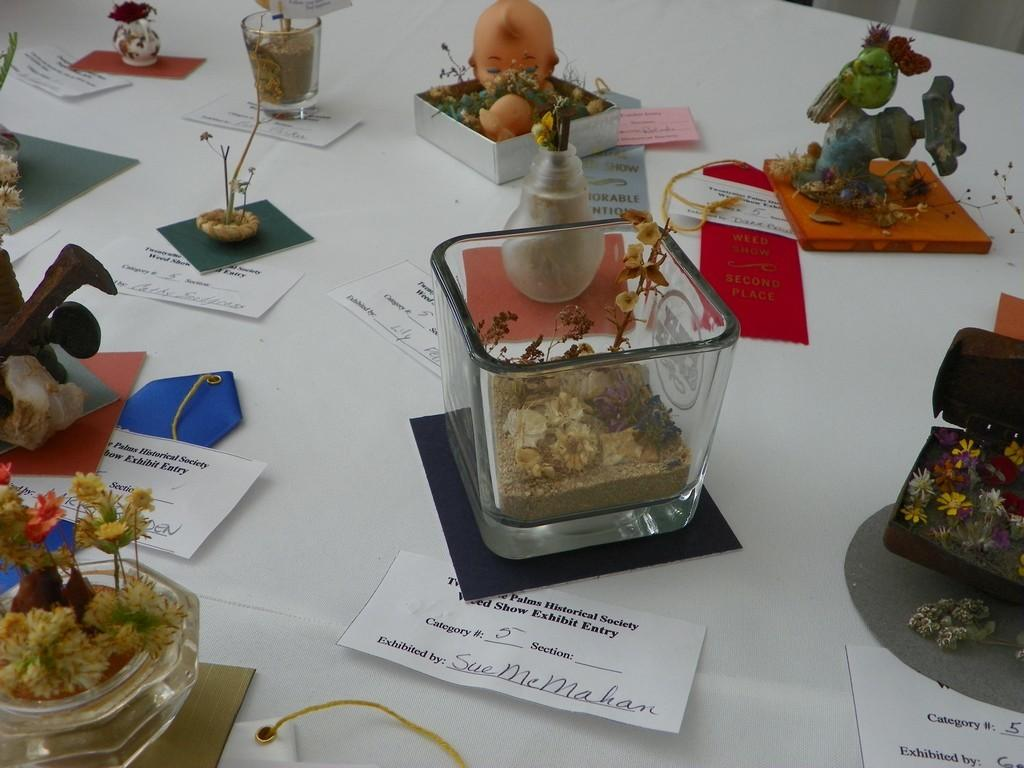What is the primary color of the surface in the image? The primary color of the surface in the image is white. What celestial bodies can be seen on the white surface? Planets are visible on the white surface. What type of object is present on the white surface? A: There is a toy on the white surface. What are the containers used for on the white surface? The containers are used for holding or storing items on the white surface. What other objects can be seen on the white surface? Other objects are visible on the white surface, but their specific nature is not mentioned in the facts. What type of written material is present in the image? Paper notes are present in the image. What type of meat is being served on the pies in the image? There are no pies or meat present in the image; it features a white surface with planets, a toy, containers, other objects, and paper notes. 